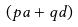Convert formula to latex. <formula><loc_0><loc_0><loc_500><loc_500>( p a + q d )</formula> 